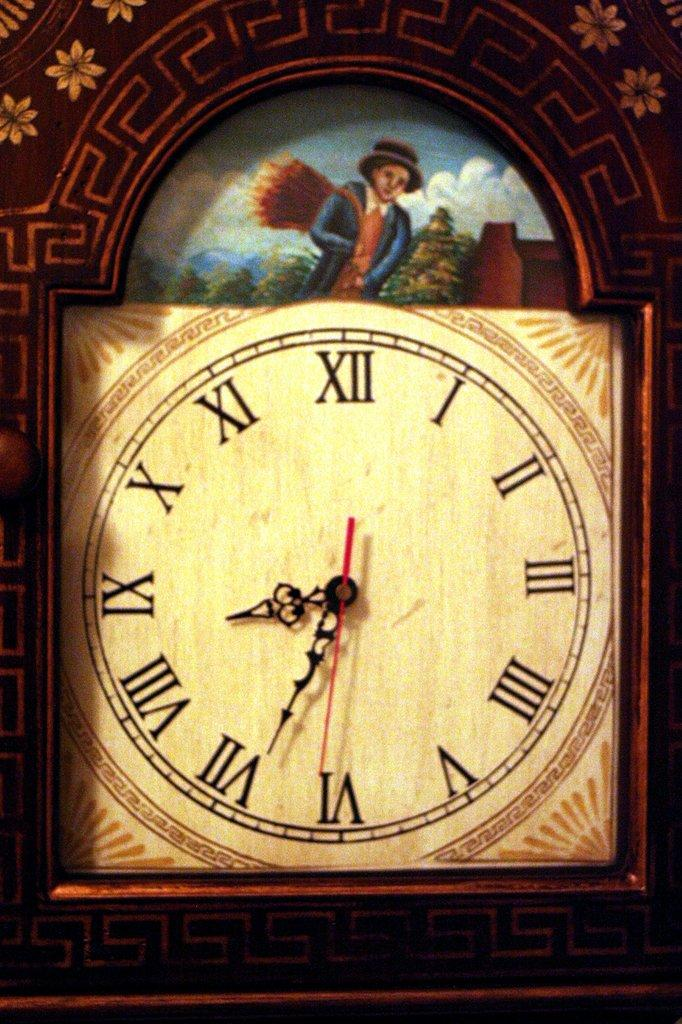<image>
Offer a succinct explanation of the picture presented. Roman numeral clock with a man in a picture in the middle of the clock 